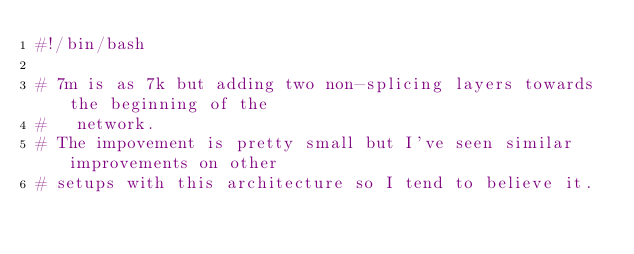<code> <loc_0><loc_0><loc_500><loc_500><_Bash_>#!/bin/bash

# 7m is as 7k but adding two non-splicing layers towards the beginning of the
#   network.
# The impovement is pretty small but I've seen similar improvements on other
# setups with this architecture so I tend to believe it.

</code> 